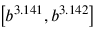Convert formula to latex. <formula><loc_0><loc_0><loc_500><loc_500>\left [ b ^ { 3 . 1 4 1 } , b ^ { 3 . 1 4 2 } \right ]</formula> 